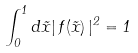Convert formula to latex. <formula><loc_0><loc_0><loc_500><loc_500>\int _ { 0 } ^ { 1 } d \tilde { x } | \, f ( \tilde { x } ) \, | ^ { 2 } = 1</formula> 